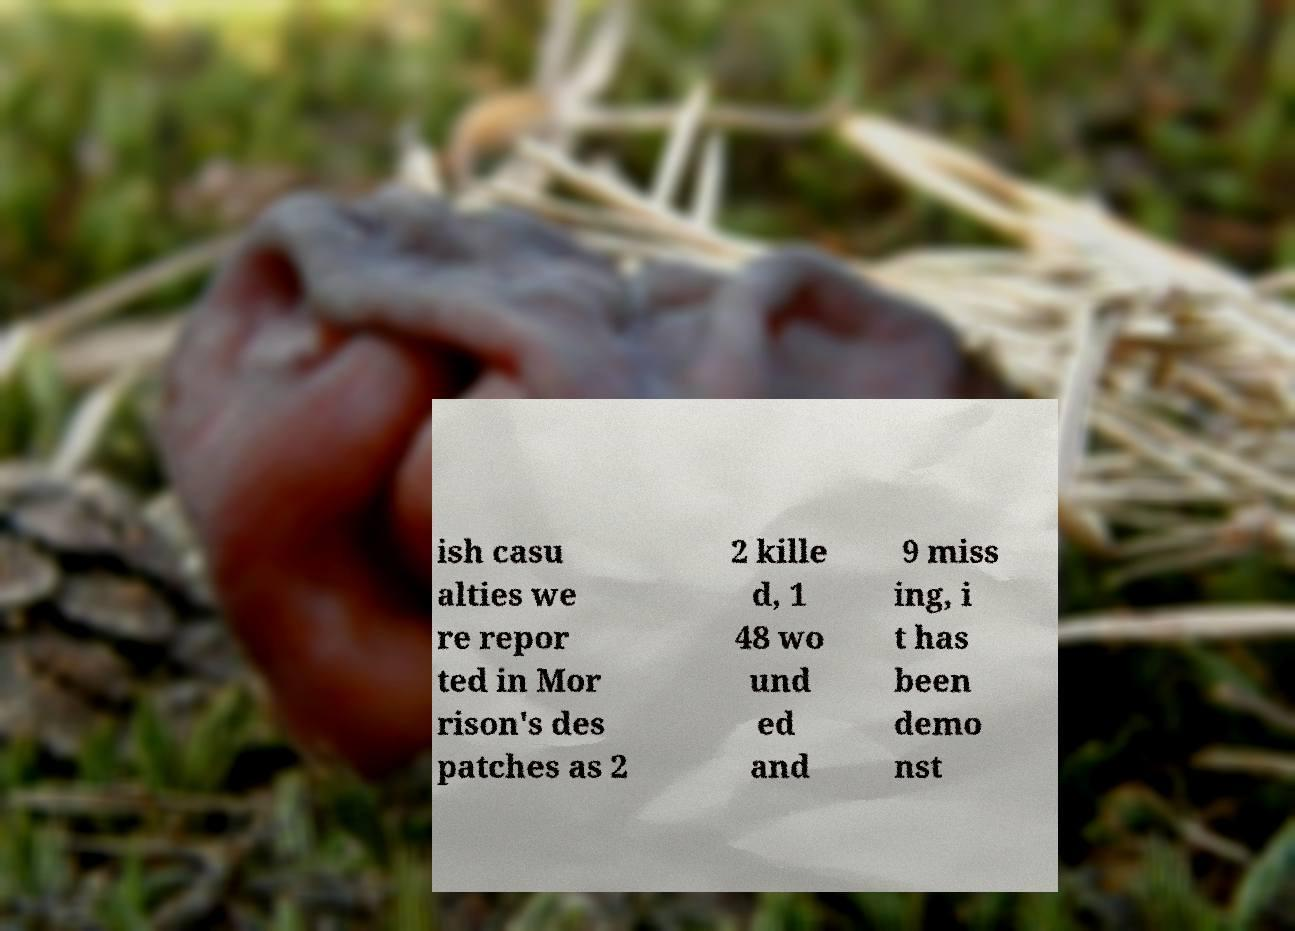Could you assist in decoding the text presented in this image and type it out clearly? ish casu alties we re repor ted in Mor rison's des patches as 2 2 kille d, 1 48 wo und ed and 9 miss ing, i t has been demo nst 